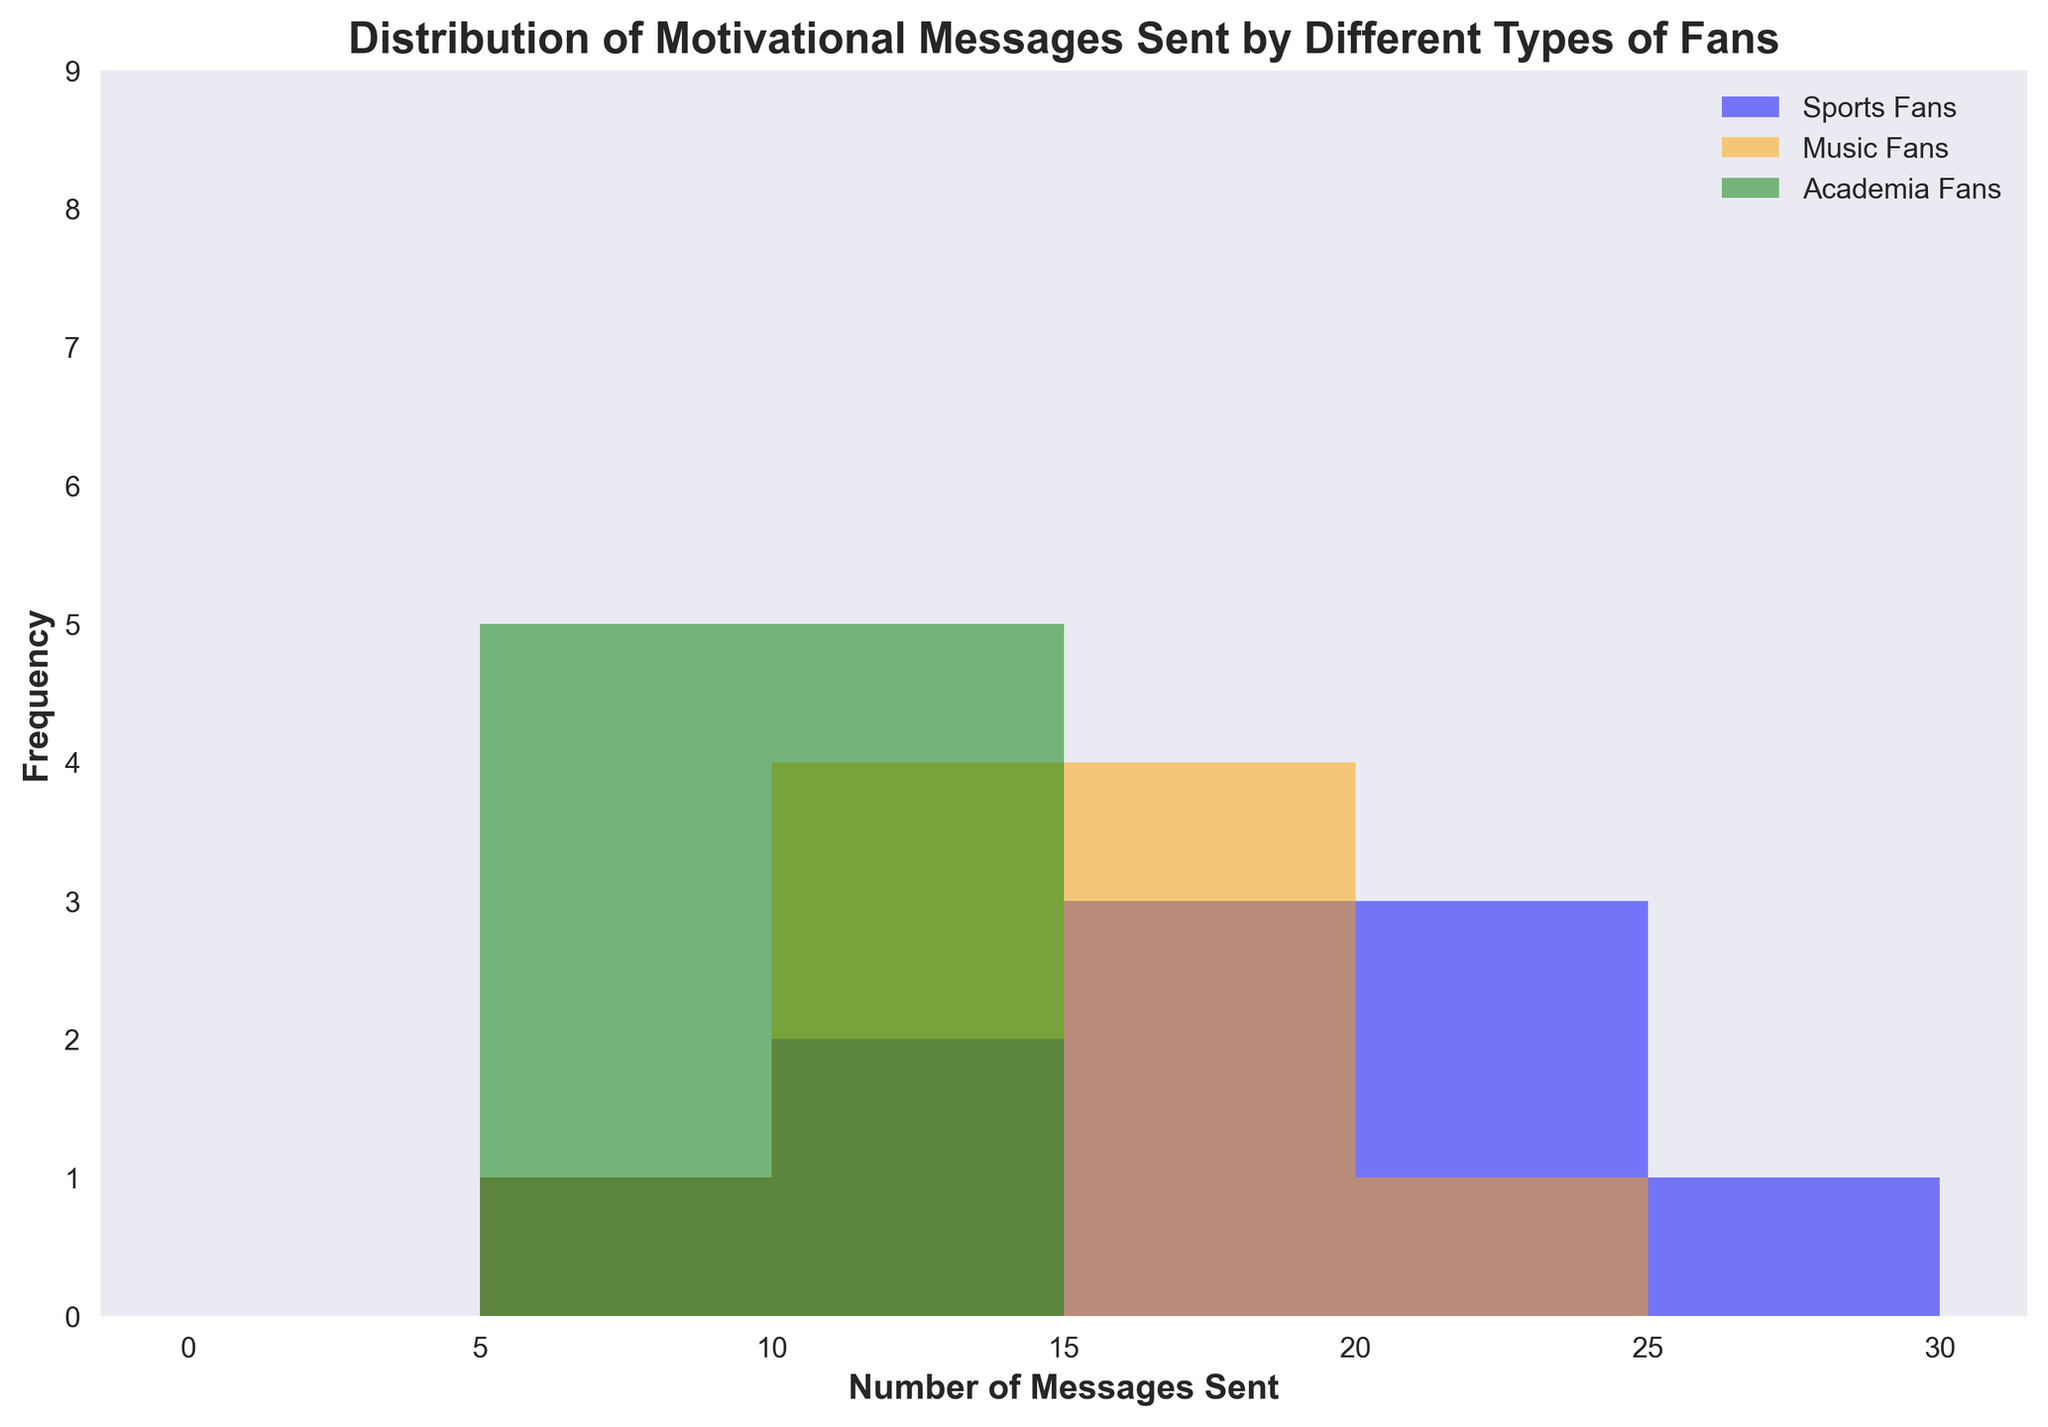What is the most frequent number of messages sent by sports fans? Look for the value at the top height of the blue bars in the histogram to find the most frequent number of messages sent by sports fans.
Answer: 20 How many sports fans sent more than 15 messages? Identify the bars representing sports fans (blue) to the right of the 15 messages mark and sum their heights.
Answer: 5 What is the range of messages sent by music fans? Identify the smallest and largest number of messages sent by music fans (orange bars), then subtract the smallest from the largest.
Answer: 9 to 20 Which fan group has the smallest range in the number of messages sent? Compare the ranges of messages for sports fans (blue), music fans (orange), and academia fans (green). The smallest range corresponds to the group with the smallest difference between the highest and lowest values.
Answer: Academia fans What is the total number of messages sent by academia fans? Sum the heights of all green bars representing the academia fans in the histogram.
Answer: 7 Which group has a higher frequency in the 15-20 message range, sports fans or music fans? Compare the heights of the blue and orange bars in the 15-20 messages range and see which is greater.
Answer: Music fans What is the overall median number of messages sent across all three fan groups? List all the numbers of messages from each group in ascending order and find the middle value. If there is an even number of data points, average the two middle values.
Answer: 13 How many distinct bins are used for grouping the data in the histogram? Count the number of bins displayed on the x-axis of the histogram.
Answer: 7 Which fan group has the highest peak frequency in the histogram? Identify which color (blue, orange, or green) has the tallest bar in the histogram.
Answer: Sports fans 